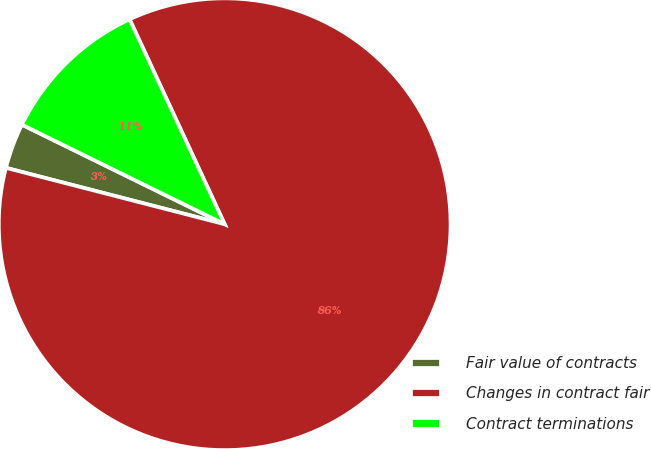Convert chart. <chart><loc_0><loc_0><loc_500><loc_500><pie_chart><fcel>Fair value of contracts<fcel>Changes in contract fair<fcel>Contract terminations<nl><fcel>3.25%<fcel>85.93%<fcel>10.82%<nl></chart> 